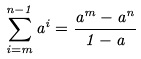Convert formula to latex. <formula><loc_0><loc_0><loc_500><loc_500>\sum _ { i = m } ^ { n - 1 } a ^ { i } = \frac { a ^ { m } - a ^ { n } } { 1 - a }</formula> 